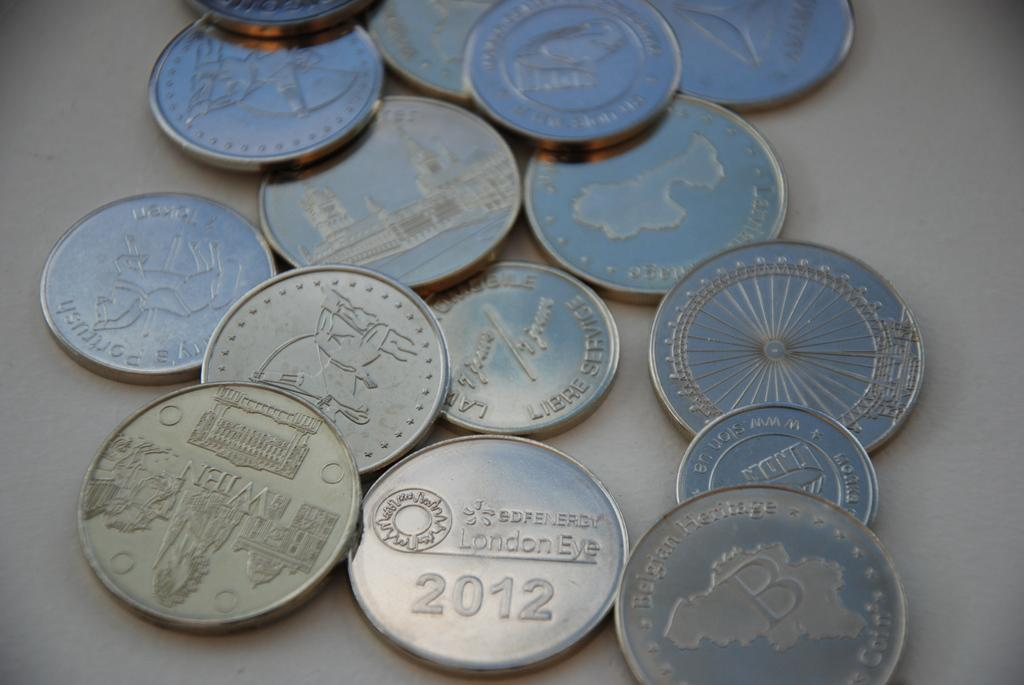<image>
Render a clear and concise summary of the photo. A collection of coins including one that was minted in 2012. 